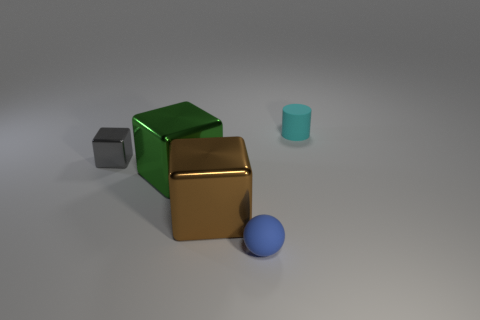Are there fewer small things than small cubes?
Make the answer very short. No. Are there any shiny things that are behind the tiny matte thing that is behind the rubber object left of the cyan cylinder?
Give a very brief answer. No. How many metal objects are blue things or big green spheres?
Keep it short and to the point. 0. Is the matte ball the same color as the tiny metal cube?
Make the answer very short. No. What number of matte things are behind the green shiny block?
Your response must be concise. 1. What number of things are behind the tiny blue sphere and in front of the small cylinder?
Make the answer very short. 3. The tiny cyan thing that is the same material as the ball is what shape?
Keep it short and to the point. Cylinder. There is a rubber object behind the green metal block; is its size the same as the rubber thing that is in front of the gray metallic cube?
Offer a terse response. Yes. What is the color of the matte object that is in front of the cyan cylinder?
Give a very brief answer. Blue. What material is the thing right of the matte thing that is in front of the tiny gray metal cube?
Offer a very short reply. Rubber. 